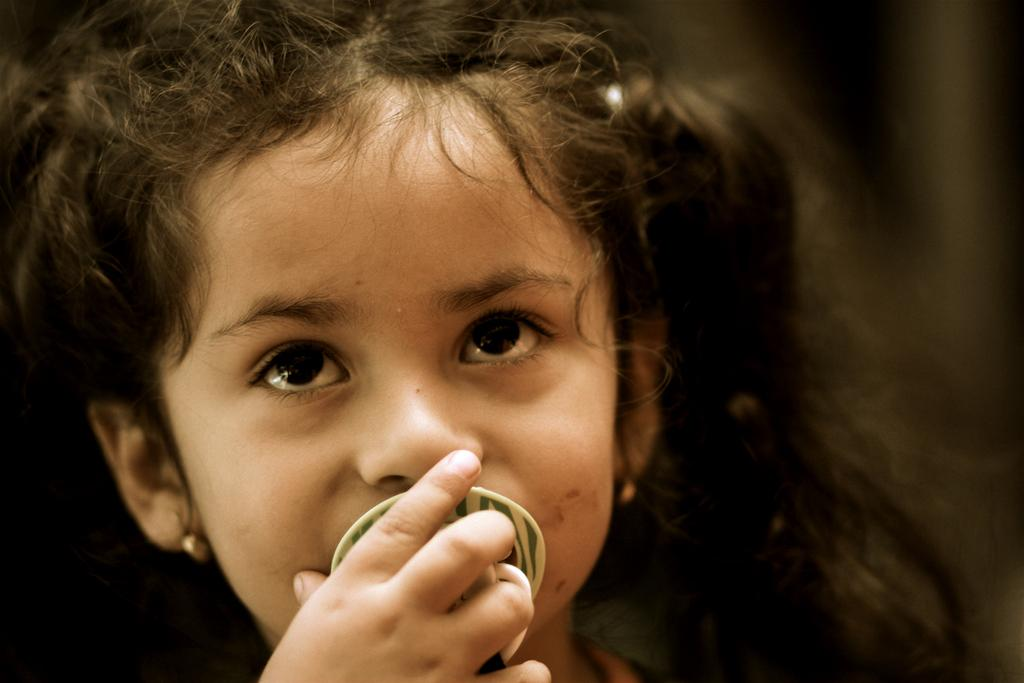Who is the main subject in the image? There is a girl in the image. What is the girl doing in the image? The girl is holding an object in the image. Where is the girl and the object located in the image? The girl and the object are in the center of the image. What type of plane can be seen in the image? There is no plane present in the image. How long has the girl been on her journey, as depicted in the image? The image does not provide any information about a journey, so it cannot be determined from the image. 